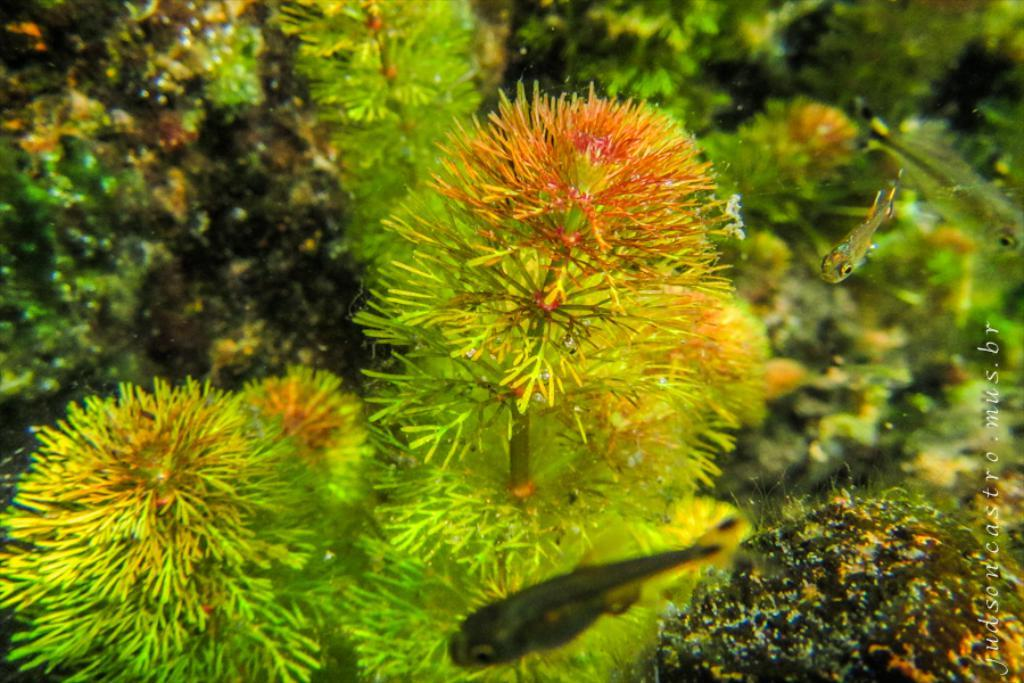What type of living organisms can be seen in the image? Plants and fishes are visible in the image. Can you describe the plants in the image? Unfortunately, the facts provided do not give specific details about the plants in the image. How many fishes are visible in the image? The facts provided do not specify the number of fishes in the image. What color are the toes of the fishes in the image? There are no toes present on the fishes in the image, as fishes do not have toes. How does the beginner learn to make eggnog in the image? There is no mention of eggnog or learning in the image, as the facts provided only mention plants and fishes. 